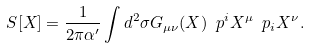<formula> <loc_0><loc_0><loc_500><loc_500>S [ X ] = \frac { 1 } { 2 \pi \alpha ^ { \prime } } \int d ^ { 2 } \sigma G _ { \mu \nu } ( X ) \ p ^ { i } X ^ { \mu } \ p _ { i } X ^ { \nu } .</formula> 